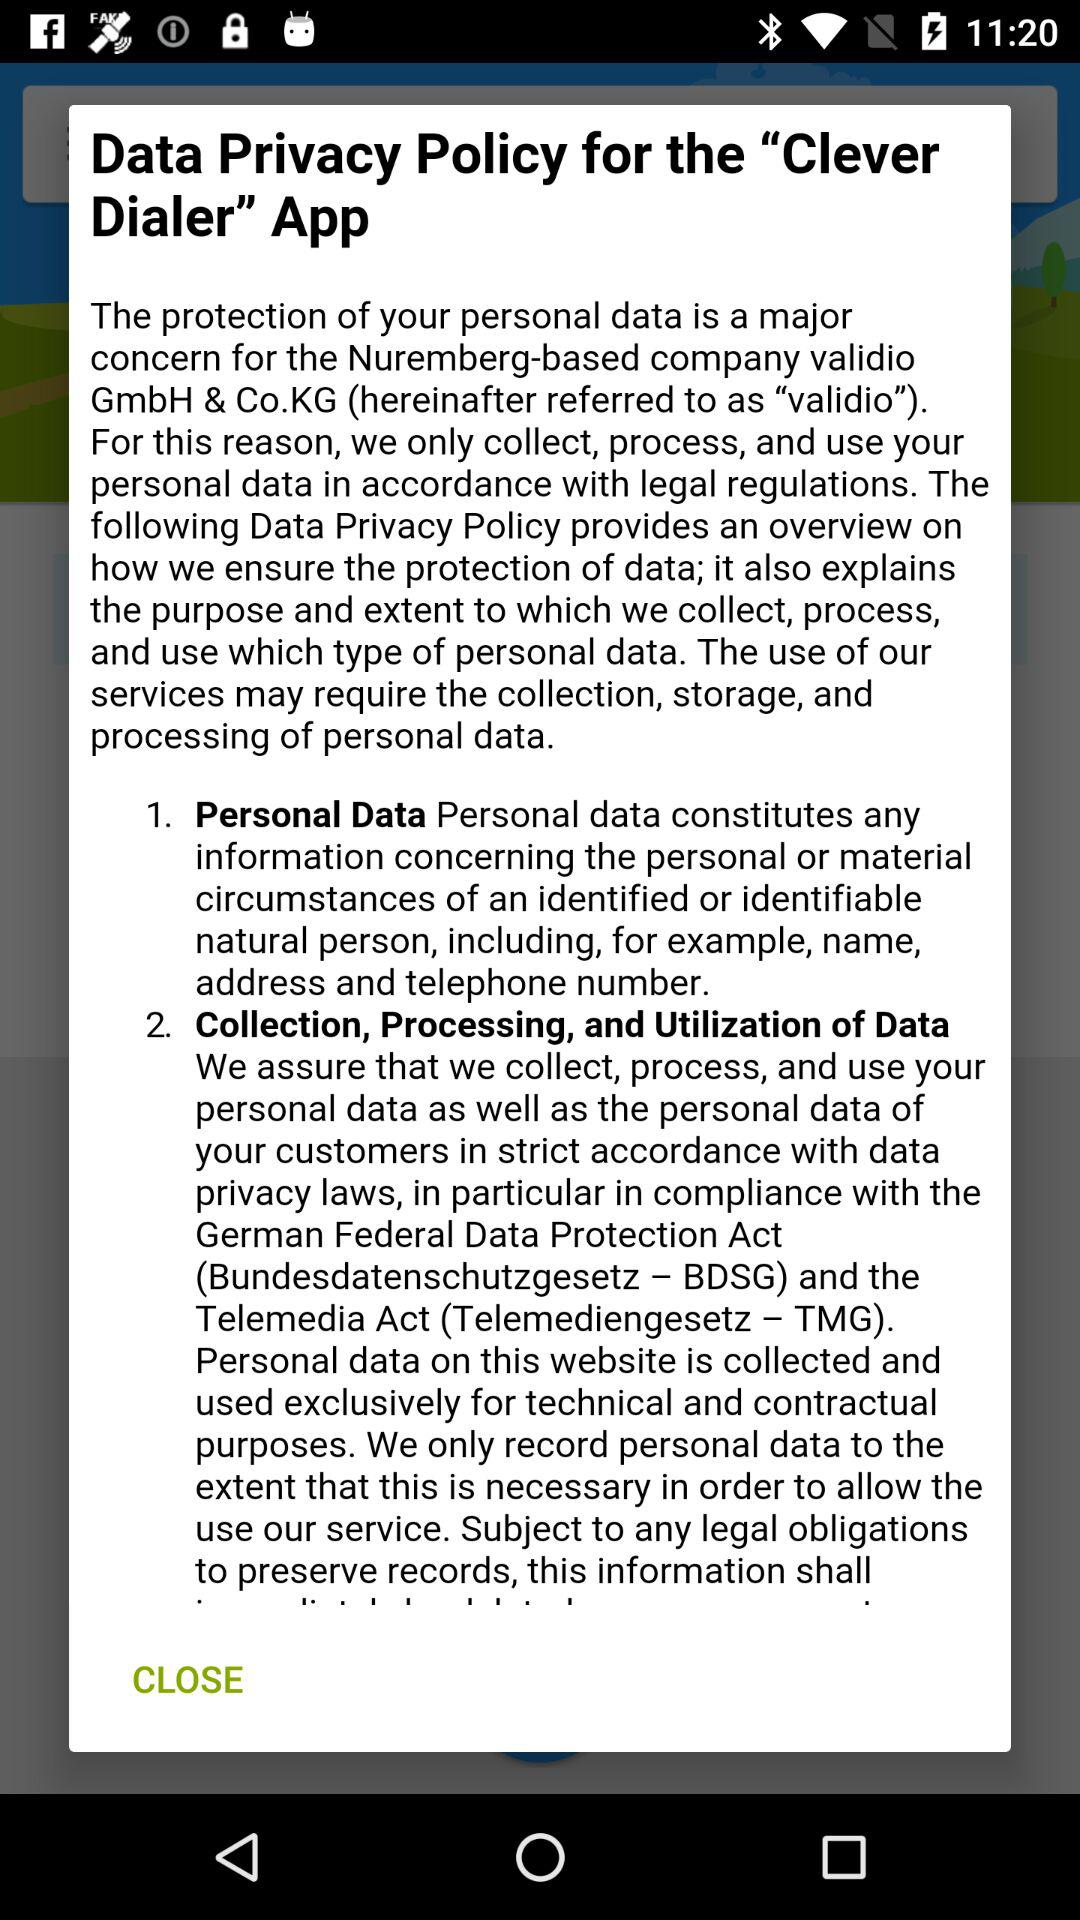How much does the "Clever Dialer" app cost?
When the provided information is insufficient, respond with <no answer>. <no answer> 